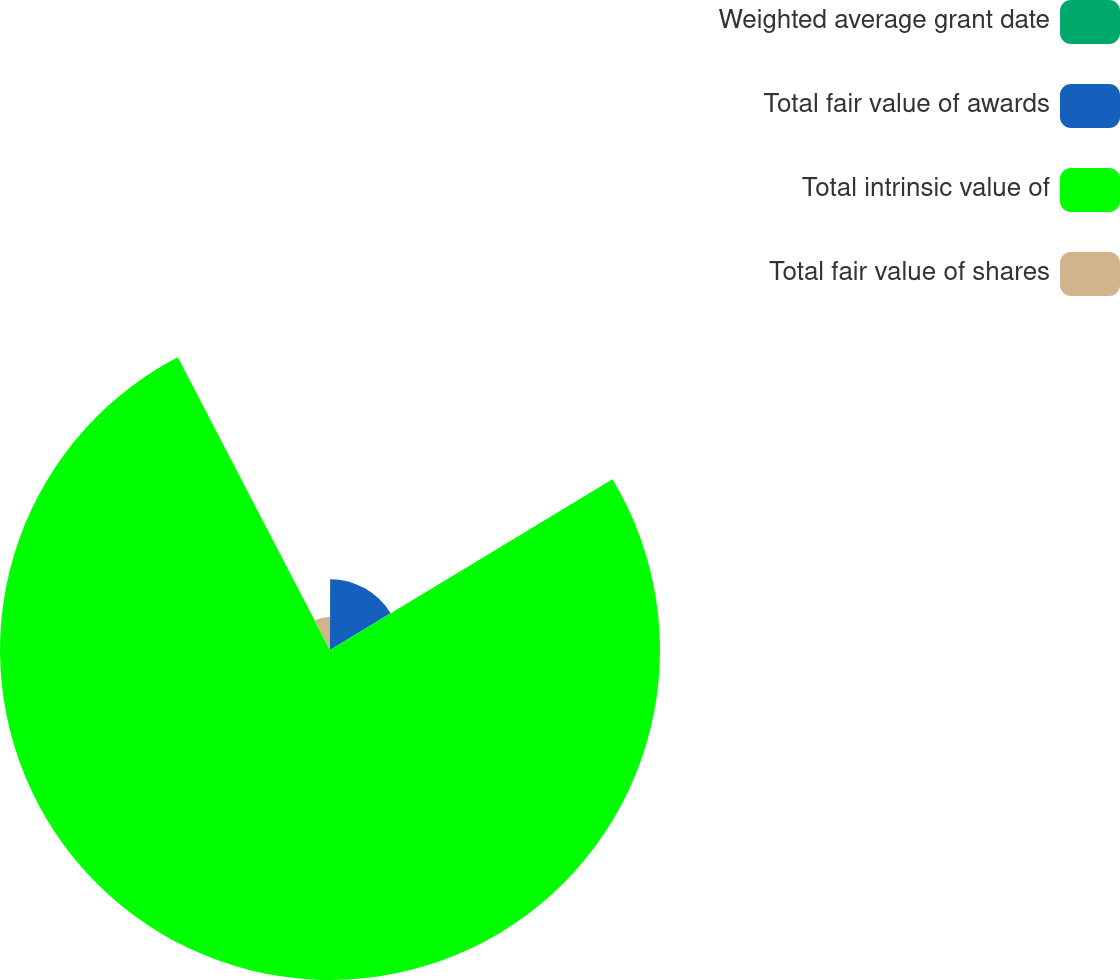<chart> <loc_0><loc_0><loc_500><loc_500><pie_chart><fcel>Weighted average grant date<fcel>Total fair value of awards<fcel>Total intrinsic value of<fcel>Total fair value of shares<nl><fcel>0.03%<fcel>16.32%<fcel>76.03%<fcel>7.63%<nl></chart> 